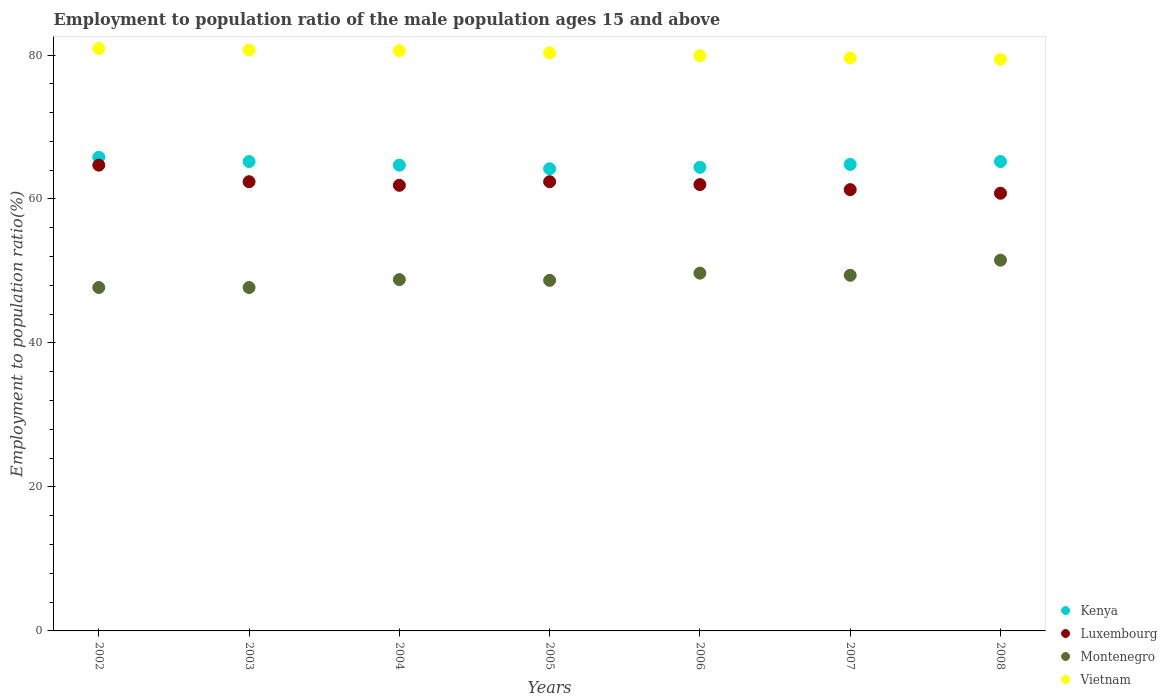Is the number of dotlines equal to the number of legend labels?
Offer a terse response. Yes. What is the employment to population ratio in Luxembourg in 2005?
Your answer should be compact. 62.4. Across all years, what is the maximum employment to population ratio in Vietnam?
Your answer should be very brief. 80.9. Across all years, what is the minimum employment to population ratio in Kenya?
Keep it short and to the point. 64.2. What is the total employment to population ratio in Kenya in the graph?
Your response must be concise. 454.3. What is the difference between the employment to population ratio in Vietnam in 2003 and that in 2008?
Your answer should be very brief. 1.3. What is the difference between the employment to population ratio in Vietnam in 2004 and the employment to population ratio in Luxembourg in 2002?
Provide a succinct answer. 15.9. What is the average employment to population ratio in Kenya per year?
Your answer should be compact. 64.9. In the year 2003, what is the difference between the employment to population ratio in Vietnam and employment to population ratio in Luxembourg?
Offer a terse response. 18.3. In how many years, is the employment to population ratio in Montenegro greater than 16 %?
Your answer should be very brief. 7. What is the ratio of the employment to population ratio in Vietnam in 2002 to that in 2004?
Ensure brevity in your answer.  1. What is the difference between the highest and the second highest employment to population ratio in Montenegro?
Provide a short and direct response. 1.8. In how many years, is the employment to population ratio in Vietnam greater than the average employment to population ratio in Vietnam taken over all years?
Offer a terse response. 4. Is it the case that in every year, the sum of the employment to population ratio in Vietnam and employment to population ratio in Montenegro  is greater than the sum of employment to population ratio in Luxembourg and employment to population ratio in Kenya?
Your answer should be very brief. Yes. Does the employment to population ratio in Vietnam monotonically increase over the years?
Provide a short and direct response. No. What is the difference between two consecutive major ticks on the Y-axis?
Offer a very short reply. 20. Are the values on the major ticks of Y-axis written in scientific E-notation?
Give a very brief answer. No. Where does the legend appear in the graph?
Your response must be concise. Bottom right. What is the title of the graph?
Give a very brief answer. Employment to population ratio of the male population ages 15 and above. Does "Burkina Faso" appear as one of the legend labels in the graph?
Offer a very short reply. No. What is the label or title of the X-axis?
Your response must be concise. Years. What is the Employment to population ratio(%) in Kenya in 2002?
Make the answer very short. 65.8. What is the Employment to population ratio(%) of Luxembourg in 2002?
Make the answer very short. 64.7. What is the Employment to population ratio(%) in Montenegro in 2002?
Your response must be concise. 47.7. What is the Employment to population ratio(%) in Vietnam in 2002?
Offer a very short reply. 80.9. What is the Employment to population ratio(%) of Kenya in 2003?
Offer a very short reply. 65.2. What is the Employment to population ratio(%) of Luxembourg in 2003?
Give a very brief answer. 62.4. What is the Employment to population ratio(%) in Montenegro in 2003?
Your answer should be compact. 47.7. What is the Employment to population ratio(%) of Vietnam in 2003?
Your response must be concise. 80.7. What is the Employment to population ratio(%) in Kenya in 2004?
Keep it short and to the point. 64.7. What is the Employment to population ratio(%) of Luxembourg in 2004?
Your response must be concise. 61.9. What is the Employment to population ratio(%) in Montenegro in 2004?
Ensure brevity in your answer.  48.8. What is the Employment to population ratio(%) in Vietnam in 2004?
Give a very brief answer. 80.6. What is the Employment to population ratio(%) in Kenya in 2005?
Offer a very short reply. 64.2. What is the Employment to population ratio(%) in Luxembourg in 2005?
Give a very brief answer. 62.4. What is the Employment to population ratio(%) of Montenegro in 2005?
Ensure brevity in your answer.  48.7. What is the Employment to population ratio(%) in Vietnam in 2005?
Ensure brevity in your answer.  80.3. What is the Employment to population ratio(%) in Kenya in 2006?
Ensure brevity in your answer.  64.4. What is the Employment to population ratio(%) of Luxembourg in 2006?
Offer a very short reply. 62. What is the Employment to population ratio(%) of Montenegro in 2006?
Your response must be concise. 49.7. What is the Employment to population ratio(%) in Vietnam in 2006?
Provide a short and direct response. 79.9. What is the Employment to population ratio(%) of Kenya in 2007?
Keep it short and to the point. 64.8. What is the Employment to population ratio(%) of Luxembourg in 2007?
Ensure brevity in your answer.  61.3. What is the Employment to population ratio(%) of Montenegro in 2007?
Ensure brevity in your answer.  49.4. What is the Employment to population ratio(%) in Vietnam in 2007?
Your answer should be compact. 79.6. What is the Employment to population ratio(%) in Kenya in 2008?
Your answer should be very brief. 65.2. What is the Employment to population ratio(%) of Luxembourg in 2008?
Ensure brevity in your answer.  60.8. What is the Employment to population ratio(%) of Montenegro in 2008?
Your answer should be compact. 51.5. What is the Employment to population ratio(%) in Vietnam in 2008?
Offer a very short reply. 79.4. Across all years, what is the maximum Employment to population ratio(%) of Kenya?
Offer a terse response. 65.8. Across all years, what is the maximum Employment to population ratio(%) in Luxembourg?
Your answer should be very brief. 64.7. Across all years, what is the maximum Employment to population ratio(%) in Montenegro?
Offer a terse response. 51.5. Across all years, what is the maximum Employment to population ratio(%) of Vietnam?
Your answer should be compact. 80.9. Across all years, what is the minimum Employment to population ratio(%) of Kenya?
Your answer should be very brief. 64.2. Across all years, what is the minimum Employment to population ratio(%) in Luxembourg?
Keep it short and to the point. 60.8. Across all years, what is the minimum Employment to population ratio(%) in Montenegro?
Offer a terse response. 47.7. Across all years, what is the minimum Employment to population ratio(%) of Vietnam?
Offer a terse response. 79.4. What is the total Employment to population ratio(%) of Kenya in the graph?
Make the answer very short. 454.3. What is the total Employment to population ratio(%) of Luxembourg in the graph?
Offer a terse response. 435.5. What is the total Employment to population ratio(%) in Montenegro in the graph?
Provide a short and direct response. 343.5. What is the total Employment to population ratio(%) of Vietnam in the graph?
Your answer should be very brief. 561.4. What is the difference between the Employment to population ratio(%) in Kenya in 2002 and that in 2003?
Your answer should be compact. 0.6. What is the difference between the Employment to population ratio(%) in Montenegro in 2002 and that in 2003?
Ensure brevity in your answer.  0. What is the difference between the Employment to population ratio(%) of Kenya in 2002 and that in 2004?
Make the answer very short. 1.1. What is the difference between the Employment to population ratio(%) of Luxembourg in 2002 and that in 2004?
Your answer should be very brief. 2.8. What is the difference between the Employment to population ratio(%) in Montenegro in 2002 and that in 2004?
Keep it short and to the point. -1.1. What is the difference between the Employment to population ratio(%) of Luxembourg in 2002 and that in 2005?
Give a very brief answer. 2.3. What is the difference between the Employment to population ratio(%) in Montenegro in 2002 and that in 2005?
Give a very brief answer. -1. What is the difference between the Employment to population ratio(%) of Vietnam in 2002 and that in 2005?
Make the answer very short. 0.6. What is the difference between the Employment to population ratio(%) of Vietnam in 2002 and that in 2006?
Provide a succinct answer. 1. What is the difference between the Employment to population ratio(%) of Kenya in 2002 and that in 2007?
Ensure brevity in your answer.  1. What is the difference between the Employment to population ratio(%) of Luxembourg in 2002 and that in 2007?
Provide a succinct answer. 3.4. What is the difference between the Employment to population ratio(%) in Luxembourg in 2003 and that in 2004?
Offer a very short reply. 0.5. What is the difference between the Employment to population ratio(%) in Montenegro in 2003 and that in 2004?
Offer a terse response. -1.1. What is the difference between the Employment to population ratio(%) in Kenya in 2003 and that in 2005?
Offer a terse response. 1. What is the difference between the Employment to population ratio(%) in Montenegro in 2003 and that in 2006?
Your answer should be compact. -2. What is the difference between the Employment to population ratio(%) of Vietnam in 2003 and that in 2006?
Make the answer very short. 0.8. What is the difference between the Employment to population ratio(%) in Luxembourg in 2003 and that in 2007?
Provide a short and direct response. 1.1. What is the difference between the Employment to population ratio(%) in Montenegro in 2003 and that in 2007?
Make the answer very short. -1.7. What is the difference between the Employment to population ratio(%) of Luxembourg in 2003 and that in 2008?
Keep it short and to the point. 1.6. What is the difference between the Employment to population ratio(%) of Vietnam in 2003 and that in 2008?
Offer a terse response. 1.3. What is the difference between the Employment to population ratio(%) of Kenya in 2004 and that in 2005?
Ensure brevity in your answer.  0.5. What is the difference between the Employment to population ratio(%) in Montenegro in 2004 and that in 2005?
Ensure brevity in your answer.  0.1. What is the difference between the Employment to population ratio(%) of Kenya in 2004 and that in 2006?
Provide a short and direct response. 0.3. What is the difference between the Employment to population ratio(%) of Luxembourg in 2004 and that in 2006?
Your response must be concise. -0.1. What is the difference between the Employment to population ratio(%) in Montenegro in 2004 and that in 2006?
Your answer should be very brief. -0.9. What is the difference between the Employment to population ratio(%) of Kenya in 2004 and that in 2007?
Offer a very short reply. -0.1. What is the difference between the Employment to population ratio(%) of Kenya in 2004 and that in 2008?
Ensure brevity in your answer.  -0.5. What is the difference between the Employment to population ratio(%) in Luxembourg in 2004 and that in 2008?
Offer a very short reply. 1.1. What is the difference between the Employment to population ratio(%) of Vietnam in 2004 and that in 2008?
Make the answer very short. 1.2. What is the difference between the Employment to population ratio(%) of Kenya in 2005 and that in 2006?
Your answer should be very brief. -0.2. What is the difference between the Employment to population ratio(%) in Montenegro in 2005 and that in 2006?
Keep it short and to the point. -1. What is the difference between the Employment to population ratio(%) of Vietnam in 2005 and that in 2006?
Ensure brevity in your answer.  0.4. What is the difference between the Employment to population ratio(%) in Kenya in 2005 and that in 2007?
Offer a terse response. -0.6. What is the difference between the Employment to population ratio(%) in Montenegro in 2005 and that in 2007?
Your answer should be compact. -0.7. What is the difference between the Employment to population ratio(%) in Montenegro in 2005 and that in 2008?
Provide a short and direct response. -2.8. What is the difference between the Employment to population ratio(%) in Vietnam in 2005 and that in 2008?
Offer a very short reply. 0.9. What is the difference between the Employment to population ratio(%) in Kenya in 2006 and that in 2008?
Offer a very short reply. -0.8. What is the difference between the Employment to population ratio(%) of Luxembourg in 2006 and that in 2008?
Your response must be concise. 1.2. What is the difference between the Employment to population ratio(%) of Montenegro in 2006 and that in 2008?
Provide a short and direct response. -1.8. What is the difference between the Employment to population ratio(%) of Kenya in 2007 and that in 2008?
Offer a terse response. -0.4. What is the difference between the Employment to population ratio(%) in Luxembourg in 2007 and that in 2008?
Ensure brevity in your answer.  0.5. What is the difference between the Employment to population ratio(%) of Montenegro in 2007 and that in 2008?
Make the answer very short. -2.1. What is the difference between the Employment to population ratio(%) of Kenya in 2002 and the Employment to population ratio(%) of Montenegro in 2003?
Offer a terse response. 18.1. What is the difference between the Employment to population ratio(%) in Kenya in 2002 and the Employment to population ratio(%) in Vietnam in 2003?
Your answer should be very brief. -14.9. What is the difference between the Employment to population ratio(%) in Luxembourg in 2002 and the Employment to population ratio(%) in Montenegro in 2003?
Your response must be concise. 17. What is the difference between the Employment to population ratio(%) in Montenegro in 2002 and the Employment to population ratio(%) in Vietnam in 2003?
Your response must be concise. -33. What is the difference between the Employment to population ratio(%) in Kenya in 2002 and the Employment to population ratio(%) in Luxembourg in 2004?
Offer a very short reply. 3.9. What is the difference between the Employment to population ratio(%) in Kenya in 2002 and the Employment to population ratio(%) in Vietnam in 2004?
Ensure brevity in your answer.  -14.8. What is the difference between the Employment to population ratio(%) in Luxembourg in 2002 and the Employment to population ratio(%) in Montenegro in 2004?
Provide a short and direct response. 15.9. What is the difference between the Employment to population ratio(%) of Luxembourg in 2002 and the Employment to population ratio(%) of Vietnam in 2004?
Offer a terse response. -15.9. What is the difference between the Employment to population ratio(%) in Montenegro in 2002 and the Employment to population ratio(%) in Vietnam in 2004?
Give a very brief answer. -32.9. What is the difference between the Employment to population ratio(%) in Kenya in 2002 and the Employment to population ratio(%) in Luxembourg in 2005?
Make the answer very short. 3.4. What is the difference between the Employment to population ratio(%) in Kenya in 2002 and the Employment to population ratio(%) in Montenegro in 2005?
Provide a short and direct response. 17.1. What is the difference between the Employment to population ratio(%) in Kenya in 2002 and the Employment to population ratio(%) in Vietnam in 2005?
Offer a very short reply. -14.5. What is the difference between the Employment to population ratio(%) of Luxembourg in 2002 and the Employment to population ratio(%) of Montenegro in 2005?
Keep it short and to the point. 16. What is the difference between the Employment to population ratio(%) in Luxembourg in 2002 and the Employment to population ratio(%) in Vietnam in 2005?
Provide a succinct answer. -15.6. What is the difference between the Employment to population ratio(%) in Montenegro in 2002 and the Employment to population ratio(%) in Vietnam in 2005?
Provide a short and direct response. -32.6. What is the difference between the Employment to population ratio(%) of Kenya in 2002 and the Employment to population ratio(%) of Vietnam in 2006?
Offer a terse response. -14.1. What is the difference between the Employment to population ratio(%) of Luxembourg in 2002 and the Employment to population ratio(%) of Montenegro in 2006?
Keep it short and to the point. 15. What is the difference between the Employment to population ratio(%) in Luxembourg in 2002 and the Employment to population ratio(%) in Vietnam in 2006?
Your answer should be very brief. -15.2. What is the difference between the Employment to population ratio(%) of Montenegro in 2002 and the Employment to population ratio(%) of Vietnam in 2006?
Offer a terse response. -32.2. What is the difference between the Employment to population ratio(%) in Kenya in 2002 and the Employment to population ratio(%) in Luxembourg in 2007?
Your answer should be very brief. 4.5. What is the difference between the Employment to population ratio(%) of Luxembourg in 2002 and the Employment to population ratio(%) of Montenegro in 2007?
Offer a very short reply. 15.3. What is the difference between the Employment to population ratio(%) in Luxembourg in 2002 and the Employment to population ratio(%) in Vietnam in 2007?
Offer a terse response. -14.9. What is the difference between the Employment to population ratio(%) in Montenegro in 2002 and the Employment to population ratio(%) in Vietnam in 2007?
Keep it short and to the point. -31.9. What is the difference between the Employment to population ratio(%) of Kenya in 2002 and the Employment to population ratio(%) of Luxembourg in 2008?
Your answer should be compact. 5. What is the difference between the Employment to population ratio(%) of Kenya in 2002 and the Employment to population ratio(%) of Montenegro in 2008?
Your answer should be very brief. 14.3. What is the difference between the Employment to population ratio(%) in Kenya in 2002 and the Employment to population ratio(%) in Vietnam in 2008?
Keep it short and to the point. -13.6. What is the difference between the Employment to population ratio(%) in Luxembourg in 2002 and the Employment to population ratio(%) in Montenegro in 2008?
Your answer should be compact. 13.2. What is the difference between the Employment to population ratio(%) of Luxembourg in 2002 and the Employment to population ratio(%) of Vietnam in 2008?
Offer a terse response. -14.7. What is the difference between the Employment to population ratio(%) in Montenegro in 2002 and the Employment to population ratio(%) in Vietnam in 2008?
Offer a very short reply. -31.7. What is the difference between the Employment to population ratio(%) in Kenya in 2003 and the Employment to population ratio(%) in Luxembourg in 2004?
Keep it short and to the point. 3.3. What is the difference between the Employment to population ratio(%) of Kenya in 2003 and the Employment to population ratio(%) of Montenegro in 2004?
Your answer should be very brief. 16.4. What is the difference between the Employment to population ratio(%) in Kenya in 2003 and the Employment to population ratio(%) in Vietnam in 2004?
Provide a short and direct response. -15.4. What is the difference between the Employment to population ratio(%) in Luxembourg in 2003 and the Employment to population ratio(%) in Vietnam in 2004?
Provide a succinct answer. -18.2. What is the difference between the Employment to population ratio(%) of Montenegro in 2003 and the Employment to population ratio(%) of Vietnam in 2004?
Give a very brief answer. -32.9. What is the difference between the Employment to population ratio(%) in Kenya in 2003 and the Employment to population ratio(%) in Vietnam in 2005?
Provide a succinct answer. -15.1. What is the difference between the Employment to population ratio(%) of Luxembourg in 2003 and the Employment to population ratio(%) of Vietnam in 2005?
Give a very brief answer. -17.9. What is the difference between the Employment to population ratio(%) of Montenegro in 2003 and the Employment to population ratio(%) of Vietnam in 2005?
Your response must be concise. -32.6. What is the difference between the Employment to population ratio(%) of Kenya in 2003 and the Employment to population ratio(%) of Vietnam in 2006?
Provide a short and direct response. -14.7. What is the difference between the Employment to population ratio(%) of Luxembourg in 2003 and the Employment to population ratio(%) of Vietnam in 2006?
Provide a succinct answer. -17.5. What is the difference between the Employment to population ratio(%) of Montenegro in 2003 and the Employment to population ratio(%) of Vietnam in 2006?
Your response must be concise. -32.2. What is the difference between the Employment to population ratio(%) in Kenya in 2003 and the Employment to population ratio(%) in Vietnam in 2007?
Ensure brevity in your answer.  -14.4. What is the difference between the Employment to population ratio(%) in Luxembourg in 2003 and the Employment to population ratio(%) in Vietnam in 2007?
Make the answer very short. -17.2. What is the difference between the Employment to population ratio(%) in Montenegro in 2003 and the Employment to population ratio(%) in Vietnam in 2007?
Your response must be concise. -31.9. What is the difference between the Employment to population ratio(%) of Kenya in 2003 and the Employment to population ratio(%) of Luxembourg in 2008?
Keep it short and to the point. 4.4. What is the difference between the Employment to population ratio(%) in Luxembourg in 2003 and the Employment to population ratio(%) in Montenegro in 2008?
Ensure brevity in your answer.  10.9. What is the difference between the Employment to population ratio(%) of Luxembourg in 2003 and the Employment to population ratio(%) of Vietnam in 2008?
Ensure brevity in your answer.  -17. What is the difference between the Employment to population ratio(%) of Montenegro in 2003 and the Employment to population ratio(%) of Vietnam in 2008?
Ensure brevity in your answer.  -31.7. What is the difference between the Employment to population ratio(%) of Kenya in 2004 and the Employment to population ratio(%) of Montenegro in 2005?
Ensure brevity in your answer.  16. What is the difference between the Employment to population ratio(%) of Kenya in 2004 and the Employment to population ratio(%) of Vietnam in 2005?
Your answer should be very brief. -15.6. What is the difference between the Employment to population ratio(%) of Luxembourg in 2004 and the Employment to population ratio(%) of Vietnam in 2005?
Your answer should be compact. -18.4. What is the difference between the Employment to population ratio(%) in Montenegro in 2004 and the Employment to population ratio(%) in Vietnam in 2005?
Ensure brevity in your answer.  -31.5. What is the difference between the Employment to population ratio(%) of Kenya in 2004 and the Employment to population ratio(%) of Vietnam in 2006?
Your answer should be compact. -15.2. What is the difference between the Employment to population ratio(%) of Luxembourg in 2004 and the Employment to population ratio(%) of Montenegro in 2006?
Your answer should be very brief. 12.2. What is the difference between the Employment to population ratio(%) in Montenegro in 2004 and the Employment to population ratio(%) in Vietnam in 2006?
Your answer should be compact. -31.1. What is the difference between the Employment to population ratio(%) in Kenya in 2004 and the Employment to population ratio(%) in Luxembourg in 2007?
Offer a very short reply. 3.4. What is the difference between the Employment to population ratio(%) in Kenya in 2004 and the Employment to population ratio(%) in Vietnam in 2007?
Your response must be concise. -14.9. What is the difference between the Employment to population ratio(%) of Luxembourg in 2004 and the Employment to population ratio(%) of Vietnam in 2007?
Keep it short and to the point. -17.7. What is the difference between the Employment to population ratio(%) in Montenegro in 2004 and the Employment to population ratio(%) in Vietnam in 2007?
Provide a succinct answer. -30.8. What is the difference between the Employment to population ratio(%) of Kenya in 2004 and the Employment to population ratio(%) of Montenegro in 2008?
Offer a terse response. 13.2. What is the difference between the Employment to population ratio(%) in Kenya in 2004 and the Employment to population ratio(%) in Vietnam in 2008?
Your answer should be compact. -14.7. What is the difference between the Employment to population ratio(%) of Luxembourg in 2004 and the Employment to population ratio(%) of Montenegro in 2008?
Make the answer very short. 10.4. What is the difference between the Employment to population ratio(%) in Luxembourg in 2004 and the Employment to population ratio(%) in Vietnam in 2008?
Provide a succinct answer. -17.5. What is the difference between the Employment to population ratio(%) in Montenegro in 2004 and the Employment to population ratio(%) in Vietnam in 2008?
Your response must be concise. -30.6. What is the difference between the Employment to population ratio(%) of Kenya in 2005 and the Employment to population ratio(%) of Montenegro in 2006?
Your response must be concise. 14.5. What is the difference between the Employment to population ratio(%) of Kenya in 2005 and the Employment to population ratio(%) of Vietnam in 2006?
Offer a very short reply. -15.7. What is the difference between the Employment to population ratio(%) of Luxembourg in 2005 and the Employment to population ratio(%) of Vietnam in 2006?
Your response must be concise. -17.5. What is the difference between the Employment to population ratio(%) of Montenegro in 2005 and the Employment to population ratio(%) of Vietnam in 2006?
Make the answer very short. -31.2. What is the difference between the Employment to population ratio(%) in Kenya in 2005 and the Employment to population ratio(%) in Luxembourg in 2007?
Your answer should be very brief. 2.9. What is the difference between the Employment to population ratio(%) in Kenya in 2005 and the Employment to population ratio(%) in Vietnam in 2007?
Your answer should be very brief. -15.4. What is the difference between the Employment to population ratio(%) of Luxembourg in 2005 and the Employment to population ratio(%) of Vietnam in 2007?
Keep it short and to the point. -17.2. What is the difference between the Employment to population ratio(%) in Montenegro in 2005 and the Employment to population ratio(%) in Vietnam in 2007?
Offer a terse response. -30.9. What is the difference between the Employment to population ratio(%) of Kenya in 2005 and the Employment to population ratio(%) of Montenegro in 2008?
Your answer should be very brief. 12.7. What is the difference between the Employment to population ratio(%) in Kenya in 2005 and the Employment to population ratio(%) in Vietnam in 2008?
Provide a short and direct response. -15.2. What is the difference between the Employment to population ratio(%) in Luxembourg in 2005 and the Employment to population ratio(%) in Vietnam in 2008?
Offer a terse response. -17. What is the difference between the Employment to population ratio(%) in Montenegro in 2005 and the Employment to population ratio(%) in Vietnam in 2008?
Offer a terse response. -30.7. What is the difference between the Employment to population ratio(%) in Kenya in 2006 and the Employment to population ratio(%) in Luxembourg in 2007?
Ensure brevity in your answer.  3.1. What is the difference between the Employment to population ratio(%) in Kenya in 2006 and the Employment to population ratio(%) in Vietnam in 2007?
Provide a succinct answer. -15.2. What is the difference between the Employment to population ratio(%) of Luxembourg in 2006 and the Employment to population ratio(%) of Montenegro in 2007?
Your answer should be very brief. 12.6. What is the difference between the Employment to population ratio(%) in Luxembourg in 2006 and the Employment to population ratio(%) in Vietnam in 2007?
Your answer should be compact. -17.6. What is the difference between the Employment to population ratio(%) in Montenegro in 2006 and the Employment to population ratio(%) in Vietnam in 2007?
Provide a succinct answer. -29.9. What is the difference between the Employment to population ratio(%) of Kenya in 2006 and the Employment to population ratio(%) of Montenegro in 2008?
Offer a terse response. 12.9. What is the difference between the Employment to population ratio(%) of Luxembourg in 2006 and the Employment to population ratio(%) of Montenegro in 2008?
Your answer should be very brief. 10.5. What is the difference between the Employment to population ratio(%) of Luxembourg in 2006 and the Employment to population ratio(%) of Vietnam in 2008?
Provide a short and direct response. -17.4. What is the difference between the Employment to population ratio(%) of Montenegro in 2006 and the Employment to population ratio(%) of Vietnam in 2008?
Provide a short and direct response. -29.7. What is the difference between the Employment to population ratio(%) in Kenya in 2007 and the Employment to population ratio(%) in Luxembourg in 2008?
Offer a very short reply. 4. What is the difference between the Employment to population ratio(%) of Kenya in 2007 and the Employment to population ratio(%) of Vietnam in 2008?
Offer a very short reply. -14.6. What is the difference between the Employment to population ratio(%) in Luxembourg in 2007 and the Employment to population ratio(%) in Vietnam in 2008?
Your answer should be very brief. -18.1. What is the average Employment to population ratio(%) of Kenya per year?
Make the answer very short. 64.9. What is the average Employment to population ratio(%) in Luxembourg per year?
Keep it short and to the point. 62.21. What is the average Employment to population ratio(%) of Montenegro per year?
Keep it short and to the point. 49.07. What is the average Employment to population ratio(%) in Vietnam per year?
Offer a very short reply. 80.2. In the year 2002, what is the difference between the Employment to population ratio(%) of Kenya and Employment to population ratio(%) of Montenegro?
Give a very brief answer. 18.1. In the year 2002, what is the difference between the Employment to population ratio(%) of Kenya and Employment to population ratio(%) of Vietnam?
Make the answer very short. -15.1. In the year 2002, what is the difference between the Employment to population ratio(%) of Luxembourg and Employment to population ratio(%) of Vietnam?
Offer a very short reply. -16.2. In the year 2002, what is the difference between the Employment to population ratio(%) in Montenegro and Employment to population ratio(%) in Vietnam?
Offer a terse response. -33.2. In the year 2003, what is the difference between the Employment to population ratio(%) of Kenya and Employment to population ratio(%) of Vietnam?
Give a very brief answer. -15.5. In the year 2003, what is the difference between the Employment to population ratio(%) of Luxembourg and Employment to population ratio(%) of Vietnam?
Ensure brevity in your answer.  -18.3. In the year 2003, what is the difference between the Employment to population ratio(%) of Montenegro and Employment to population ratio(%) of Vietnam?
Ensure brevity in your answer.  -33. In the year 2004, what is the difference between the Employment to population ratio(%) in Kenya and Employment to population ratio(%) in Luxembourg?
Keep it short and to the point. 2.8. In the year 2004, what is the difference between the Employment to population ratio(%) in Kenya and Employment to population ratio(%) in Montenegro?
Provide a succinct answer. 15.9. In the year 2004, what is the difference between the Employment to population ratio(%) of Kenya and Employment to population ratio(%) of Vietnam?
Your response must be concise. -15.9. In the year 2004, what is the difference between the Employment to population ratio(%) of Luxembourg and Employment to population ratio(%) of Montenegro?
Offer a terse response. 13.1. In the year 2004, what is the difference between the Employment to population ratio(%) of Luxembourg and Employment to population ratio(%) of Vietnam?
Your answer should be compact. -18.7. In the year 2004, what is the difference between the Employment to population ratio(%) of Montenegro and Employment to population ratio(%) of Vietnam?
Your answer should be compact. -31.8. In the year 2005, what is the difference between the Employment to population ratio(%) in Kenya and Employment to population ratio(%) in Luxembourg?
Provide a succinct answer. 1.8. In the year 2005, what is the difference between the Employment to population ratio(%) of Kenya and Employment to population ratio(%) of Montenegro?
Provide a succinct answer. 15.5. In the year 2005, what is the difference between the Employment to population ratio(%) in Kenya and Employment to population ratio(%) in Vietnam?
Your response must be concise. -16.1. In the year 2005, what is the difference between the Employment to population ratio(%) of Luxembourg and Employment to population ratio(%) of Vietnam?
Offer a very short reply. -17.9. In the year 2005, what is the difference between the Employment to population ratio(%) of Montenegro and Employment to population ratio(%) of Vietnam?
Offer a terse response. -31.6. In the year 2006, what is the difference between the Employment to population ratio(%) in Kenya and Employment to population ratio(%) in Vietnam?
Offer a terse response. -15.5. In the year 2006, what is the difference between the Employment to population ratio(%) of Luxembourg and Employment to population ratio(%) of Montenegro?
Give a very brief answer. 12.3. In the year 2006, what is the difference between the Employment to population ratio(%) of Luxembourg and Employment to population ratio(%) of Vietnam?
Your response must be concise. -17.9. In the year 2006, what is the difference between the Employment to population ratio(%) in Montenegro and Employment to population ratio(%) in Vietnam?
Provide a succinct answer. -30.2. In the year 2007, what is the difference between the Employment to population ratio(%) in Kenya and Employment to population ratio(%) in Luxembourg?
Provide a short and direct response. 3.5. In the year 2007, what is the difference between the Employment to population ratio(%) of Kenya and Employment to population ratio(%) of Vietnam?
Give a very brief answer. -14.8. In the year 2007, what is the difference between the Employment to population ratio(%) of Luxembourg and Employment to population ratio(%) of Montenegro?
Offer a very short reply. 11.9. In the year 2007, what is the difference between the Employment to population ratio(%) in Luxembourg and Employment to population ratio(%) in Vietnam?
Offer a very short reply. -18.3. In the year 2007, what is the difference between the Employment to population ratio(%) of Montenegro and Employment to population ratio(%) of Vietnam?
Keep it short and to the point. -30.2. In the year 2008, what is the difference between the Employment to population ratio(%) of Luxembourg and Employment to population ratio(%) of Montenegro?
Your answer should be compact. 9.3. In the year 2008, what is the difference between the Employment to population ratio(%) in Luxembourg and Employment to population ratio(%) in Vietnam?
Your response must be concise. -18.6. In the year 2008, what is the difference between the Employment to population ratio(%) in Montenegro and Employment to population ratio(%) in Vietnam?
Keep it short and to the point. -27.9. What is the ratio of the Employment to population ratio(%) in Kenya in 2002 to that in 2003?
Give a very brief answer. 1.01. What is the ratio of the Employment to population ratio(%) in Luxembourg in 2002 to that in 2003?
Provide a short and direct response. 1.04. What is the ratio of the Employment to population ratio(%) of Montenegro in 2002 to that in 2003?
Your answer should be very brief. 1. What is the ratio of the Employment to population ratio(%) of Vietnam in 2002 to that in 2003?
Give a very brief answer. 1. What is the ratio of the Employment to population ratio(%) in Luxembourg in 2002 to that in 2004?
Provide a succinct answer. 1.05. What is the ratio of the Employment to population ratio(%) of Montenegro in 2002 to that in 2004?
Provide a succinct answer. 0.98. What is the ratio of the Employment to population ratio(%) of Kenya in 2002 to that in 2005?
Offer a terse response. 1.02. What is the ratio of the Employment to population ratio(%) of Luxembourg in 2002 to that in 2005?
Offer a very short reply. 1.04. What is the ratio of the Employment to population ratio(%) of Montenegro in 2002 to that in 2005?
Offer a terse response. 0.98. What is the ratio of the Employment to population ratio(%) in Vietnam in 2002 to that in 2005?
Your response must be concise. 1.01. What is the ratio of the Employment to population ratio(%) in Kenya in 2002 to that in 2006?
Provide a short and direct response. 1.02. What is the ratio of the Employment to population ratio(%) of Luxembourg in 2002 to that in 2006?
Provide a succinct answer. 1.04. What is the ratio of the Employment to population ratio(%) of Montenegro in 2002 to that in 2006?
Give a very brief answer. 0.96. What is the ratio of the Employment to population ratio(%) in Vietnam in 2002 to that in 2006?
Give a very brief answer. 1.01. What is the ratio of the Employment to population ratio(%) in Kenya in 2002 to that in 2007?
Make the answer very short. 1.02. What is the ratio of the Employment to population ratio(%) in Luxembourg in 2002 to that in 2007?
Make the answer very short. 1.06. What is the ratio of the Employment to population ratio(%) in Montenegro in 2002 to that in 2007?
Provide a short and direct response. 0.97. What is the ratio of the Employment to population ratio(%) in Vietnam in 2002 to that in 2007?
Your response must be concise. 1.02. What is the ratio of the Employment to population ratio(%) of Kenya in 2002 to that in 2008?
Give a very brief answer. 1.01. What is the ratio of the Employment to population ratio(%) of Luxembourg in 2002 to that in 2008?
Provide a succinct answer. 1.06. What is the ratio of the Employment to population ratio(%) of Montenegro in 2002 to that in 2008?
Your answer should be very brief. 0.93. What is the ratio of the Employment to population ratio(%) of Vietnam in 2002 to that in 2008?
Your response must be concise. 1.02. What is the ratio of the Employment to population ratio(%) of Kenya in 2003 to that in 2004?
Offer a terse response. 1.01. What is the ratio of the Employment to population ratio(%) of Luxembourg in 2003 to that in 2004?
Your answer should be very brief. 1.01. What is the ratio of the Employment to population ratio(%) of Montenegro in 2003 to that in 2004?
Give a very brief answer. 0.98. What is the ratio of the Employment to population ratio(%) of Kenya in 2003 to that in 2005?
Provide a short and direct response. 1.02. What is the ratio of the Employment to population ratio(%) in Montenegro in 2003 to that in 2005?
Your response must be concise. 0.98. What is the ratio of the Employment to population ratio(%) of Kenya in 2003 to that in 2006?
Offer a very short reply. 1.01. What is the ratio of the Employment to population ratio(%) in Luxembourg in 2003 to that in 2006?
Ensure brevity in your answer.  1.01. What is the ratio of the Employment to population ratio(%) of Montenegro in 2003 to that in 2006?
Your answer should be compact. 0.96. What is the ratio of the Employment to population ratio(%) in Vietnam in 2003 to that in 2006?
Provide a short and direct response. 1.01. What is the ratio of the Employment to population ratio(%) of Luxembourg in 2003 to that in 2007?
Make the answer very short. 1.02. What is the ratio of the Employment to population ratio(%) of Montenegro in 2003 to that in 2007?
Your response must be concise. 0.97. What is the ratio of the Employment to population ratio(%) of Vietnam in 2003 to that in 2007?
Keep it short and to the point. 1.01. What is the ratio of the Employment to population ratio(%) in Luxembourg in 2003 to that in 2008?
Keep it short and to the point. 1.03. What is the ratio of the Employment to population ratio(%) in Montenegro in 2003 to that in 2008?
Make the answer very short. 0.93. What is the ratio of the Employment to population ratio(%) in Vietnam in 2003 to that in 2008?
Give a very brief answer. 1.02. What is the ratio of the Employment to population ratio(%) in Kenya in 2004 to that in 2005?
Ensure brevity in your answer.  1.01. What is the ratio of the Employment to population ratio(%) in Luxembourg in 2004 to that in 2005?
Your answer should be compact. 0.99. What is the ratio of the Employment to population ratio(%) in Vietnam in 2004 to that in 2005?
Give a very brief answer. 1. What is the ratio of the Employment to population ratio(%) in Kenya in 2004 to that in 2006?
Your response must be concise. 1. What is the ratio of the Employment to population ratio(%) of Luxembourg in 2004 to that in 2006?
Offer a very short reply. 1. What is the ratio of the Employment to population ratio(%) in Montenegro in 2004 to that in 2006?
Provide a succinct answer. 0.98. What is the ratio of the Employment to population ratio(%) of Vietnam in 2004 to that in 2006?
Your answer should be very brief. 1.01. What is the ratio of the Employment to population ratio(%) in Luxembourg in 2004 to that in 2007?
Provide a succinct answer. 1.01. What is the ratio of the Employment to population ratio(%) of Montenegro in 2004 to that in 2007?
Make the answer very short. 0.99. What is the ratio of the Employment to population ratio(%) in Vietnam in 2004 to that in 2007?
Keep it short and to the point. 1.01. What is the ratio of the Employment to population ratio(%) in Kenya in 2004 to that in 2008?
Ensure brevity in your answer.  0.99. What is the ratio of the Employment to population ratio(%) in Luxembourg in 2004 to that in 2008?
Offer a terse response. 1.02. What is the ratio of the Employment to population ratio(%) in Montenegro in 2004 to that in 2008?
Your answer should be very brief. 0.95. What is the ratio of the Employment to population ratio(%) of Vietnam in 2004 to that in 2008?
Provide a succinct answer. 1.02. What is the ratio of the Employment to population ratio(%) of Kenya in 2005 to that in 2006?
Ensure brevity in your answer.  1. What is the ratio of the Employment to population ratio(%) in Luxembourg in 2005 to that in 2006?
Give a very brief answer. 1.01. What is the ratio of the Employment to population ratio(%) in Montenegro in 2005 to that in 2006?
Offer a very short reply. 0.98. What is the ratio of the Employment to population ratio(%) of Kenya in 2005 to that in 2007?
Offer a terse response. 0.99. What is the ratio of the Employment to population ratio(%) of Luxembourg in 2005 to that in 2007?
Provide a succinct answer. 1.02. What is the ratio of the Employment to population ratio(%) in Montenegro in 2005 to that in 2007?
Your response must be concise. 0.99. What is the ratio of the Employment to population ratio(%) in Vietnam in 2005 to that in 2007?
Provide a short and direct response. 1.01. What is the ratio of the Employment to population ratio(%) of Kenya in 2005 to that in 2008?
Make the answer very short. 0.98. What is the ratio of the Employment to population ratio(%) in Luxembourg in 2005 to that in 2008?
Your answer should be very brief. 1.03. What is the ratio of the Employment to population ratio(%) in Montenegro in 2005 to that in 2008?
Provide a succinct answer. 0.95. What is the ratio of the Employment to population ratio(%) of Vietnam in 2005 to that in 2008?
Keep it short and to the point. 1.01. What is the ratio of the Employment to population ratio(%) in Kenya in 2006 to that in 2007?
Your response must be concise. 0.99. What is the ratio of the Employment to population ratio(%) in Luxembourg in 2006 to that in 2007?
Ensure brevity in your answer.  1.01. What is the ratio of the Employment to population ratio(%) in Kenya in 2006 to that in 2008?
Your answer should be compact. 0.99. What is the ratio of the Employment to population ratio(%) of Luxembourg in 2006 to that in 2008?
Make the answer very short. 1.02. What is the ratio of the Employment to population ratio(%) of Montenegro in 2006 to that in 2008?
Offer a terse response. 0.96. What is the ratio of the Employment to population ratio(%) of Kenya in 2007 to that in 2008?
Your response must be concise. 0.99. What is the ratio of the Employment to population ratio(%) in Luxembourg in 2007 to that in 2008?
Your answer should be compact. 1.01. What is the ratio of the Employment to population ratio(%) in Montenegro in 2007 to that in 2008?
Offer a terse response. 0.96. What is the difference between the highest and the lowest Employment to population ratio(%) in Kenya?
Your response must be concise. 1.6. What is the difference between the highest and the lowest Employment to population ratio(%) in Montenegro?
Ensure brevity in your answer.  3.8. 